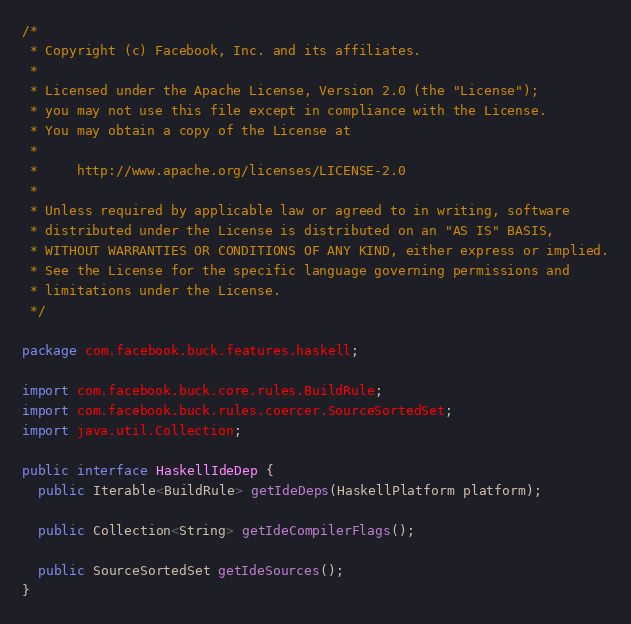Convert code to text. <code><loc_0><loc_0><loc_500><loc_500><_Java_>/*
 * Copyright (c) Facebook, Inc. and its affiliates.
 *
 * Licensed under the Apache License, Version 2.0 (the "License");
 * you may not use this file except in compliance with the License.
 * You may obtain a copy of the License at
 *
 *     http://www.apache.org/licenses/LICENSE-2.0
 *
 * Unless required by applicable law or agreed to in writing, software
 * distributed under the License is distributed on an "AS IS" BASIS,
 * WITHOUT WARRANTIES OR CONDITIONS OF ANY KIND, either express or implied.
 * See the License for the specific language governing permissions and
 * limitations under the License.
 */

package com.facebook.buck.features.haskell;

import com.facebook.buck.core.rules.BuildRule;
import com.facebook.buck.rules.coercer.SourceSortedSet;
import java.util.Collection;

public interface HaskellIdeDep {
  public Iterable<BuildRule> getIdeDeps(HaskellPlatform platform);

  public Collection<String> getIdeCompilerFlags();

  public SourceSortedSet getIdeSources();
}
</code> 